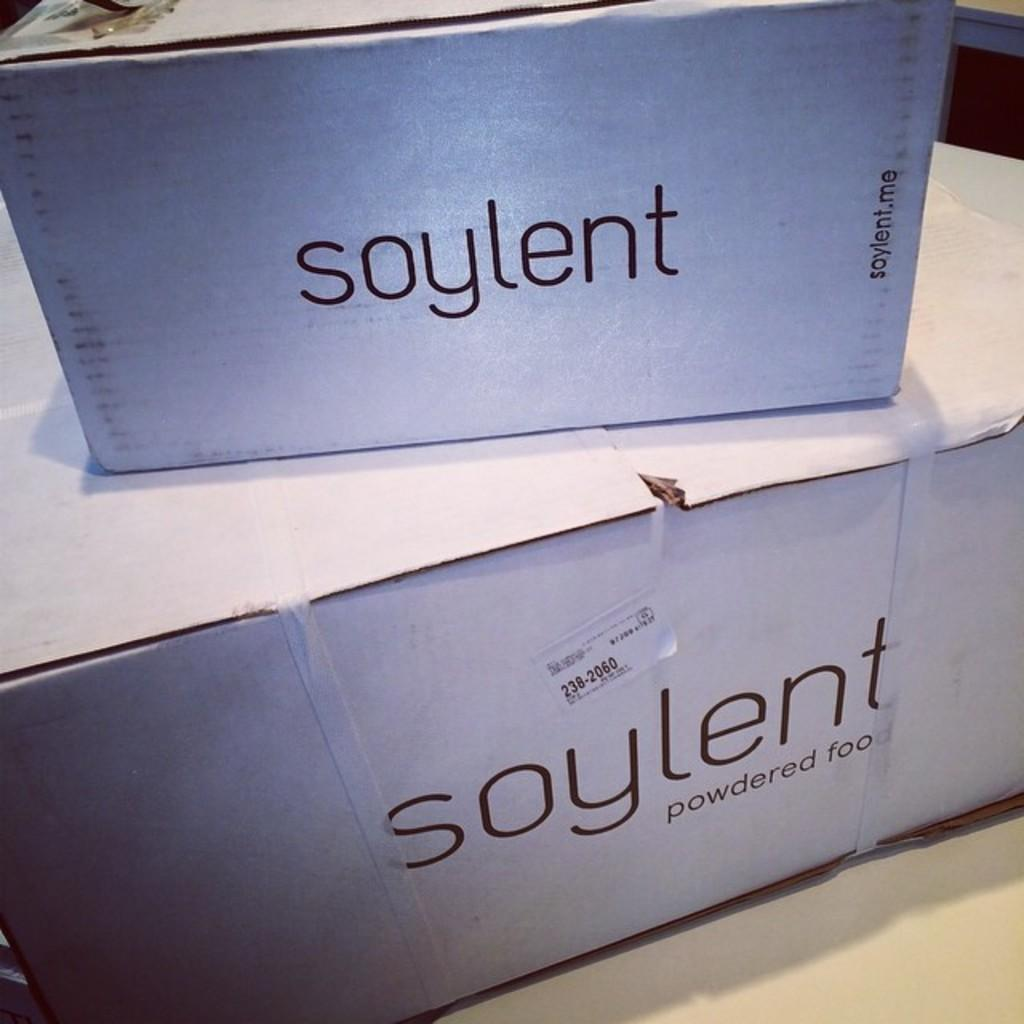<image>
Write a terse but informative summary of the picture. Two white boxes of a powdered food product called soylent. 